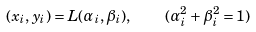<formula> <loc_0><loc_0><loc_500><loc_500>( x _ { i } , y _ { i } ) = L ( \alpha _ { i } , \beta _ { i } ) , \quad ( \alpha _ { i } ^ { 2 } + \beta _ { i } ^ { 2 } = 1 )</formula> 